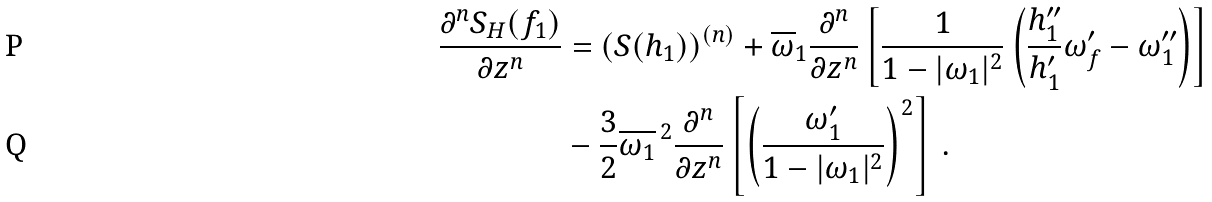Convert formula to latex. <formula><loc_0><loc_0><loc_500><loc_500>\frac { \partial ^ { n } S _ { H } ( f _ { 1 } ) } { \partial z ^ { n } } & = ( S ( h _ { 1 } ) ) ^ { ( n ) } + \overline { \omega } _ { 1 } \frac { \partial ^ { n } } { \partial z ^ { n } } \left [ \frac { 1 } { 1 - | \omega _ { 1 } | ^ { 2 } } \left ( \frac { h ^ { \prime \prime } _ { 1 } } { h ^ { \prime } _ { 1 } } \omega _ { f } ^ { \prime } - \omega ^ { \prime \prime } _ { 1 } \right ) \right ] \\ & - \frac { 3 } { 2 } \overline { \omega _ { 1 } } ^ { \, 2 } \frac { \partial ^ { n } } { \partial z ^ { n } } \left [ \left ( \frac { \omega ^ { \prime } _ { 1 } } { 1 - | \omega _ { 1 } | ^ { 2 } } \right ) ^ { 2 } \right ] \, .</formula> 